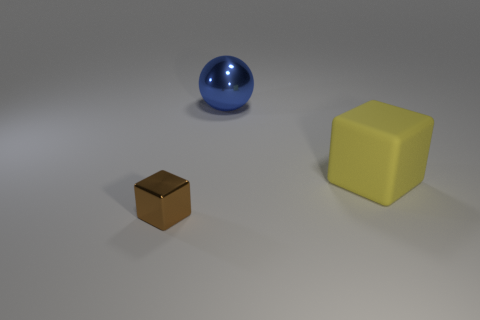Are there any other things that have the same material as the big cube?
Your answer should be compact. No. What is the large block made of?
Provide a short and direct response. Rubber. Is the material of the large blue object the same as the large block?
Provide a short and direct response. No. The sphere that is the same material as the brown object is what size?
Offer a terse response. Large. There is a object that is both right of the tiny brown shiny block and left of the large rubber object; what size is it?
Give a very brief answer. Large. What number of purple rubber blocks have the same size as the yellow matte cube?
Your response must be concise. 0. There is a large thing that is in front of the big blue sphere; does it have the same shape as the small brown thing?
Your response must be concise. Yes. Are there fewer blue metallic balls that are left of the blue metallic sphere than yellow matte cubes?
Provide a short and direct response. Yes. There is a big matte object; is it the same shape as the shiny object that is behind the tiny block?
Your answer should be compact. No. Is there a yellow cube made of the same material as the tiny thing?
Your response must be concise. No. 